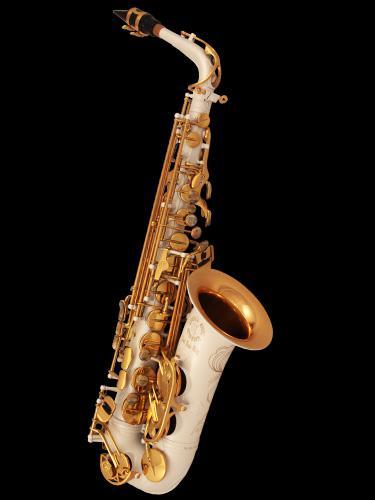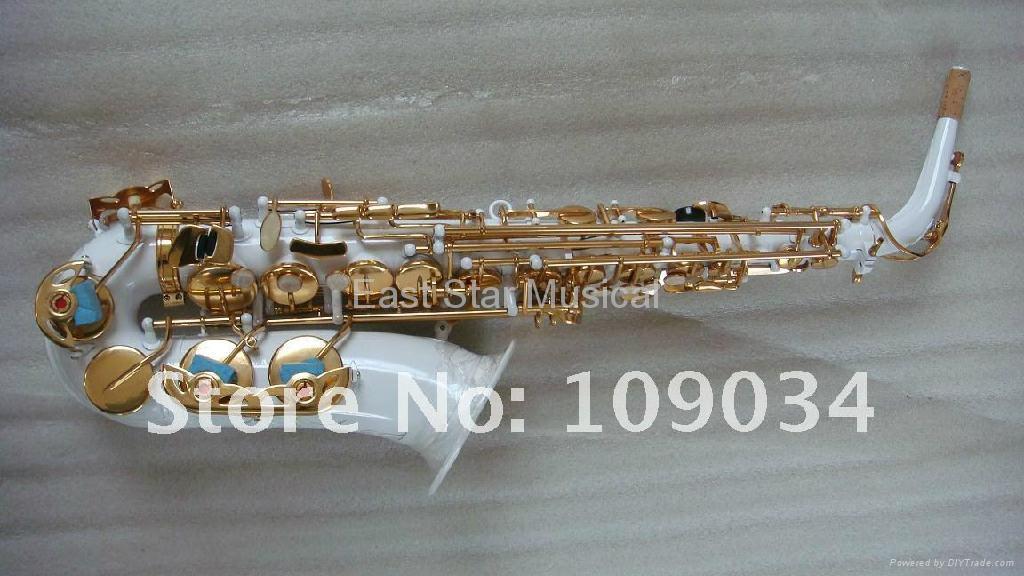The first image is the image on the left, the second image is the image on the right. For the images displayed, is the sentence "The left image shows a white saxophone witht turquoise on its gold buttons and its upturned bell facing right, and the right image shows a straight white instrument with its bell at the bottom." factually correct? Answer yes or no. No. 